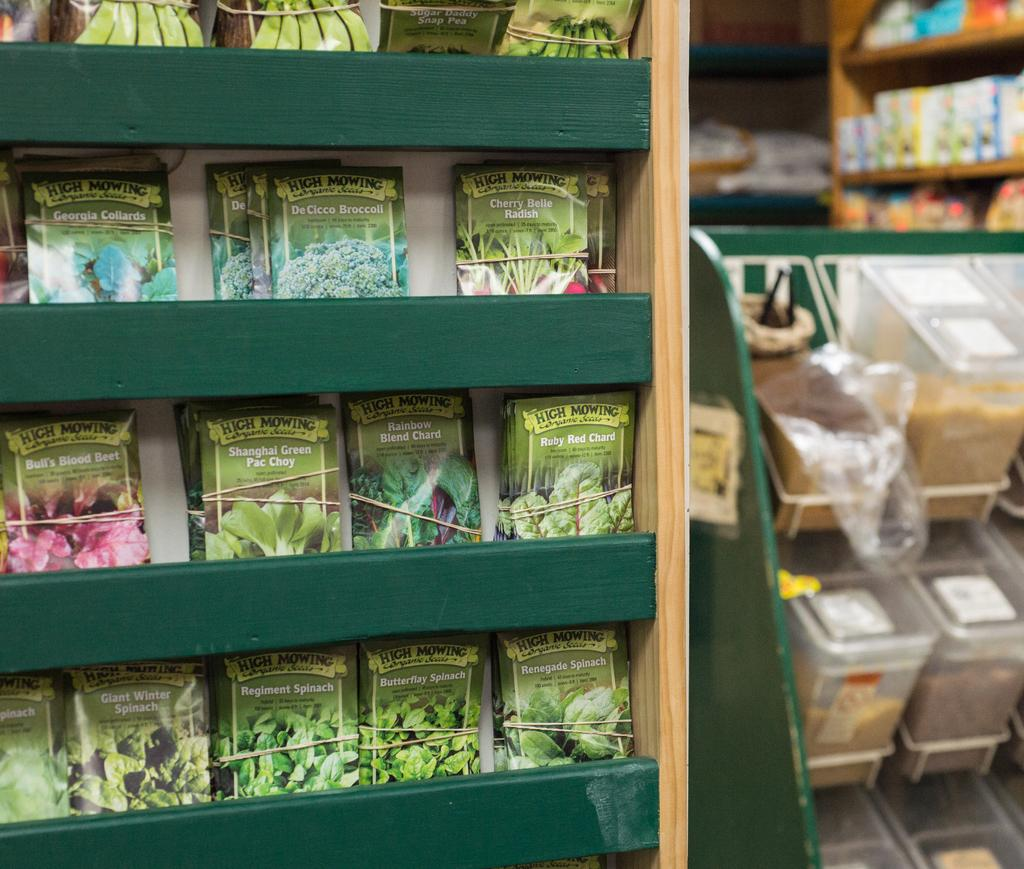<image>
Present a compact description of the photo's key features. Packets of vegetable seeds displayed on shelves in a store. 